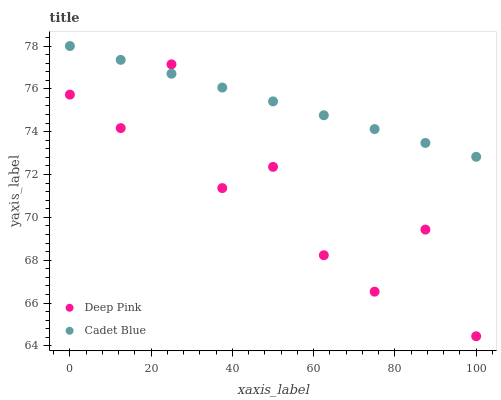Does Deep Pink have the minimum area under the curve?
Answer yes or no. Yes. Does Cadet Blue have the maximum area under the curve?
Answer yes or no. Yes. Does Deep Pink have the maximum area under the curve?
Answer yes or no. No. Is Cadet Blue the smoothest?
Answer yes or no. Yes. Is Deep Pink the roughest?
Answer yes or no. Yes. Is Deep Pink the smoothest?
Answer yes or no. No. Does Deep Pink have the lowest value?
Answer yes or no. Yes. Does Cadet Blue have the highest value?
Answer yes or no. Yes. Does Deep Pink have the highest value?
Answer yes or no. No. Does Deep Pink intersect Cadet Blue?
Answer yes or no. Yes. Is Deep Pink less than Cadet Blue?
Answer yes or no. No. Is Deep Pink greater than Cadet Blue?
Answer yes or no. No. 